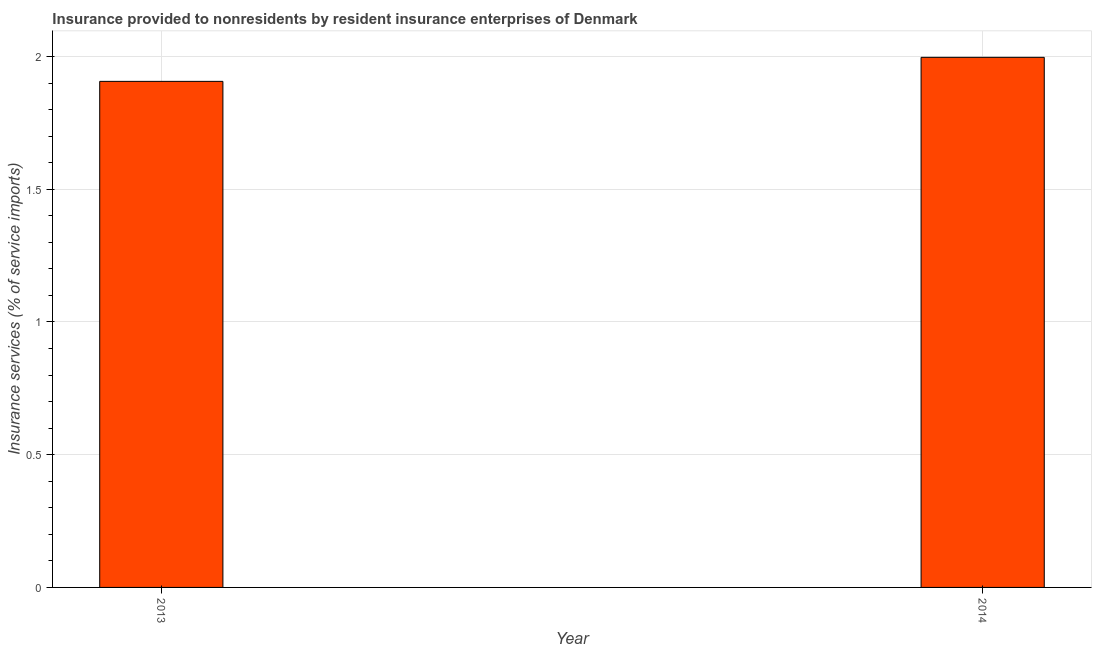Does the graph contain any zero values?
Offer a very short reply. No. What is the title of the graph?
Your answer should be compact. Insurance provided to nonresidents by resident insurance enterprises of Denmark. What is the label or title of the X-axis?
Provide a succinct answer. Year. What is the label or title of the Y-axis?
Offer a terse response. Insurance services (% of service imports). What is the insurance and financial services in 2013?
Keep it short and to the point. 1.91. Across all years, what is the maximum insurance and financial services?
Your answer should be very brief. 2. Across all years, what is the minimum insurance and financial services?
Provide a short and direct response. 1.91. In which year was the insurance and financial services maximum?
Give a very brief answer. 2014. In which year was the insurance and financial services minimum?
Your response must be concise. 2013. What is the sum of the insurance and financial services?
Ensure brevity in your answer.  3.9. What is the difference between the insurance and financial services in 2013 and 2014?
Keep it short and to the point. -0.09. What is the average insurance and financial services per year?
Provide a short and direct response. 1.95. What is the median insurance and financial services?
Your response must be concise. 1.95. In how many years, is the insurance and financial services greater than 1.4 %?
Your answer should be very brief. 2. Do a majority of the years between 2014 and 2013 (inclusive) have insurance and financial services greater than 0.8 %?
Your answer should be compact. No. What is the ratio of the insurance and financial services in 2013 to that in 2014?
Offer a very short reply. 0.95. Is the insurance and financial services in 2013 less than that in 2014?
Offer a terse response. Yes. How many bars are there?
Provide a succinct answer. 2. Are all the bars in the graph horizontal?
Your response must be concise. No. How many years are there in the graph?
Your answer should be very brief. 2. What is the difference between two consecutive major ticks on the Y-axis?
Your answer should be very brief. 0.5. Are the values on the major ticks of Y-axis written in scientific E-notation?
Your response must be concise. No. What is the Insurance services (% of service imports) in 2013?
Your answer should be very brief. 1.91. What is the Insurance services (% of service imports) in 2014?
Give a very brief answer. 2. What is the difference between the Insurance services (% of service imports) in 2013 and 2014?
Provide a short and direct response. -0.09. What is the ratio of the Insurance services (% of service imports) in 2013 to that in 2014?
Ensure brevity in your answer.  0.95. 